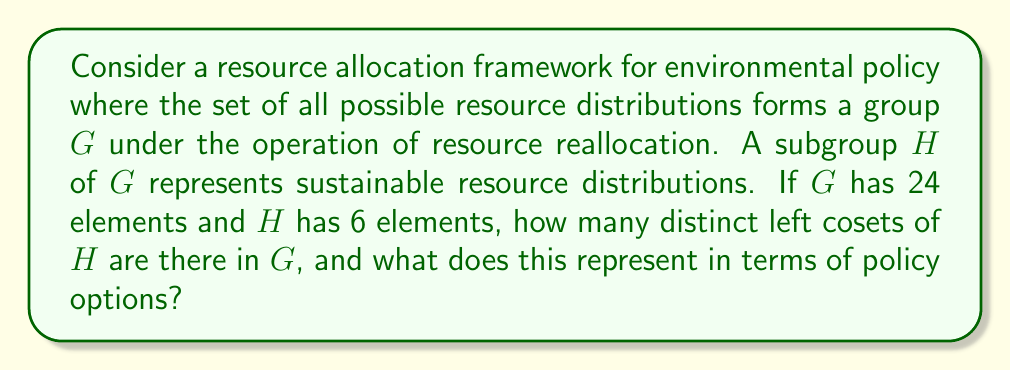Help me with this question. To solve this problem, we need to apply the concept of cosets from group theory to our resource allocation framework. Let's break it down step-by-step:

1) In group theory, the number of left cosets of a subgroup is equal to the index of the subgroup in the group. The index is denoted by $[G:H]$ and is calculated as:

   $$[G:H] = \frac{|G|}{|H|}$$

   where $|G|$ is the order (number of elements) of group $G$, and $|H|$ is the order of subgroup $H$.

2) In our case:
   $|G| = 24$ (total number of possible resource distributions)
   $|H| = 6$ (number of sustainable resource distributions)

3) Calculating the index:

   $$[G:H] = \frac{|G|}{|H|} = \frac{24}{6} = 4$$

4) Therefore, there are 4 distinct left cosets of $H$ in $G$.

5) In terms of policy options, this result can be interpreted as follows:
   - Each coset represents a class of resource distributions that are equivalent under the sustainable distributions (represented by $H$).
   - The 4 cosets divide all possible resource distributions into 4 distinct categories or policy approaches.
   - Policymakers can focus on these 4 categories when considering different resource allocation strategies, knowing that distributions within each category can be transformed into one another through sustainable reallocations.

This grouping can significantly simplify the decision-making process by reducing the number of distinct policy options to consider from 24 to 4, while still covering all possible resource distributions.
Answer: There are 4 distinct left cosets of $H$ in $G$, representing 4 main categories of resource distribution policies to consider. 